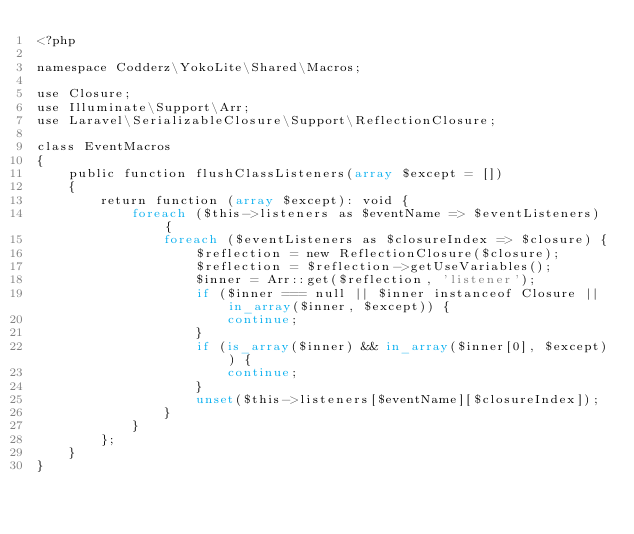Convert code to text. <code><loc_0><loc_0><loc_500><loc_500><_PHP_><?php

namespace Codderz\YokoLite\Shared\Macros;

use Closure;
use Illuminate\Support\Arr;
use Laravel\SerializableClosure\Support\ReflectionClosure;

class EventMacros
{
    public function flushClassListeners(array $except = [])
    {
        return function (array $except): void {
            foreach ($this->listeners as $eventName => $eventListeners) {
                foreach ($eventListeners as $closureIndex => $closure) {
                    $reflection = new ReflectionClosure($closure);
                    $reflection = $reflection->getUseVariables();
                    $inner = Arr::get($reflection, 'listener');
                    if ($inner === null || $inner instanceof Closure || in_array($inner, $except)) {
                        continue;
                    }
                    if (is_array($inner) && in_array($inner[0], $except)) {
                        continue;
                    }
                    unset($this->listeners[$eventName][$closureIndex]);
                }
            }
        };
    }
}
</code> 